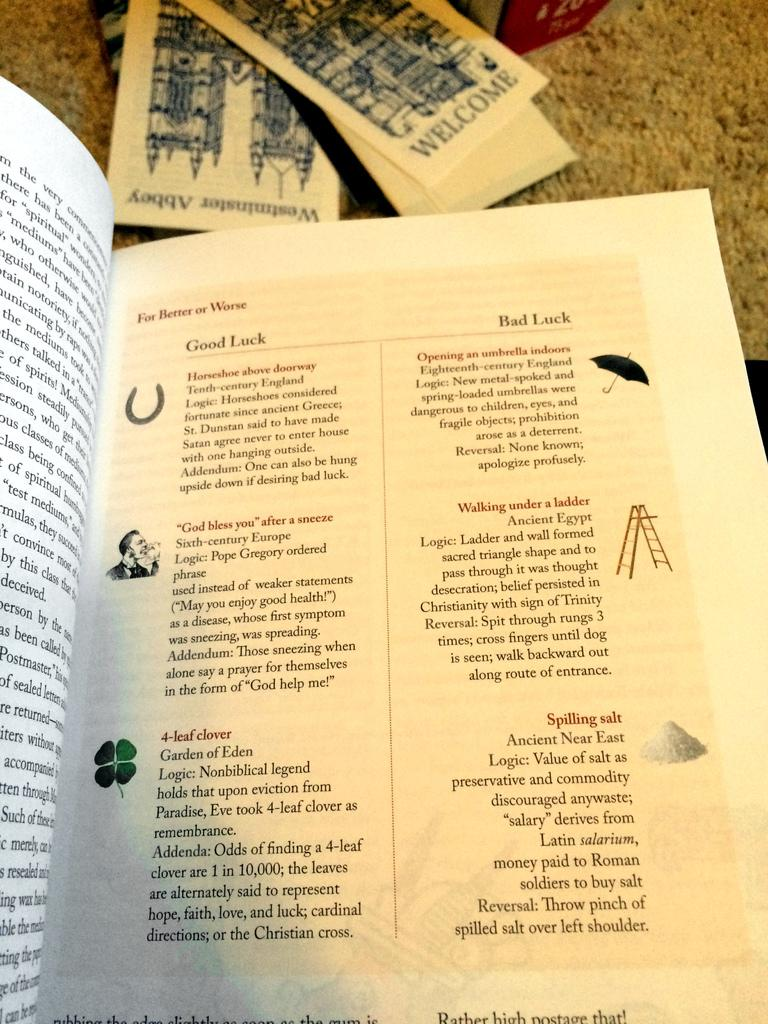<image>
Give a short and clear explanation of the subsequent image. A book page describing good and bad luck 